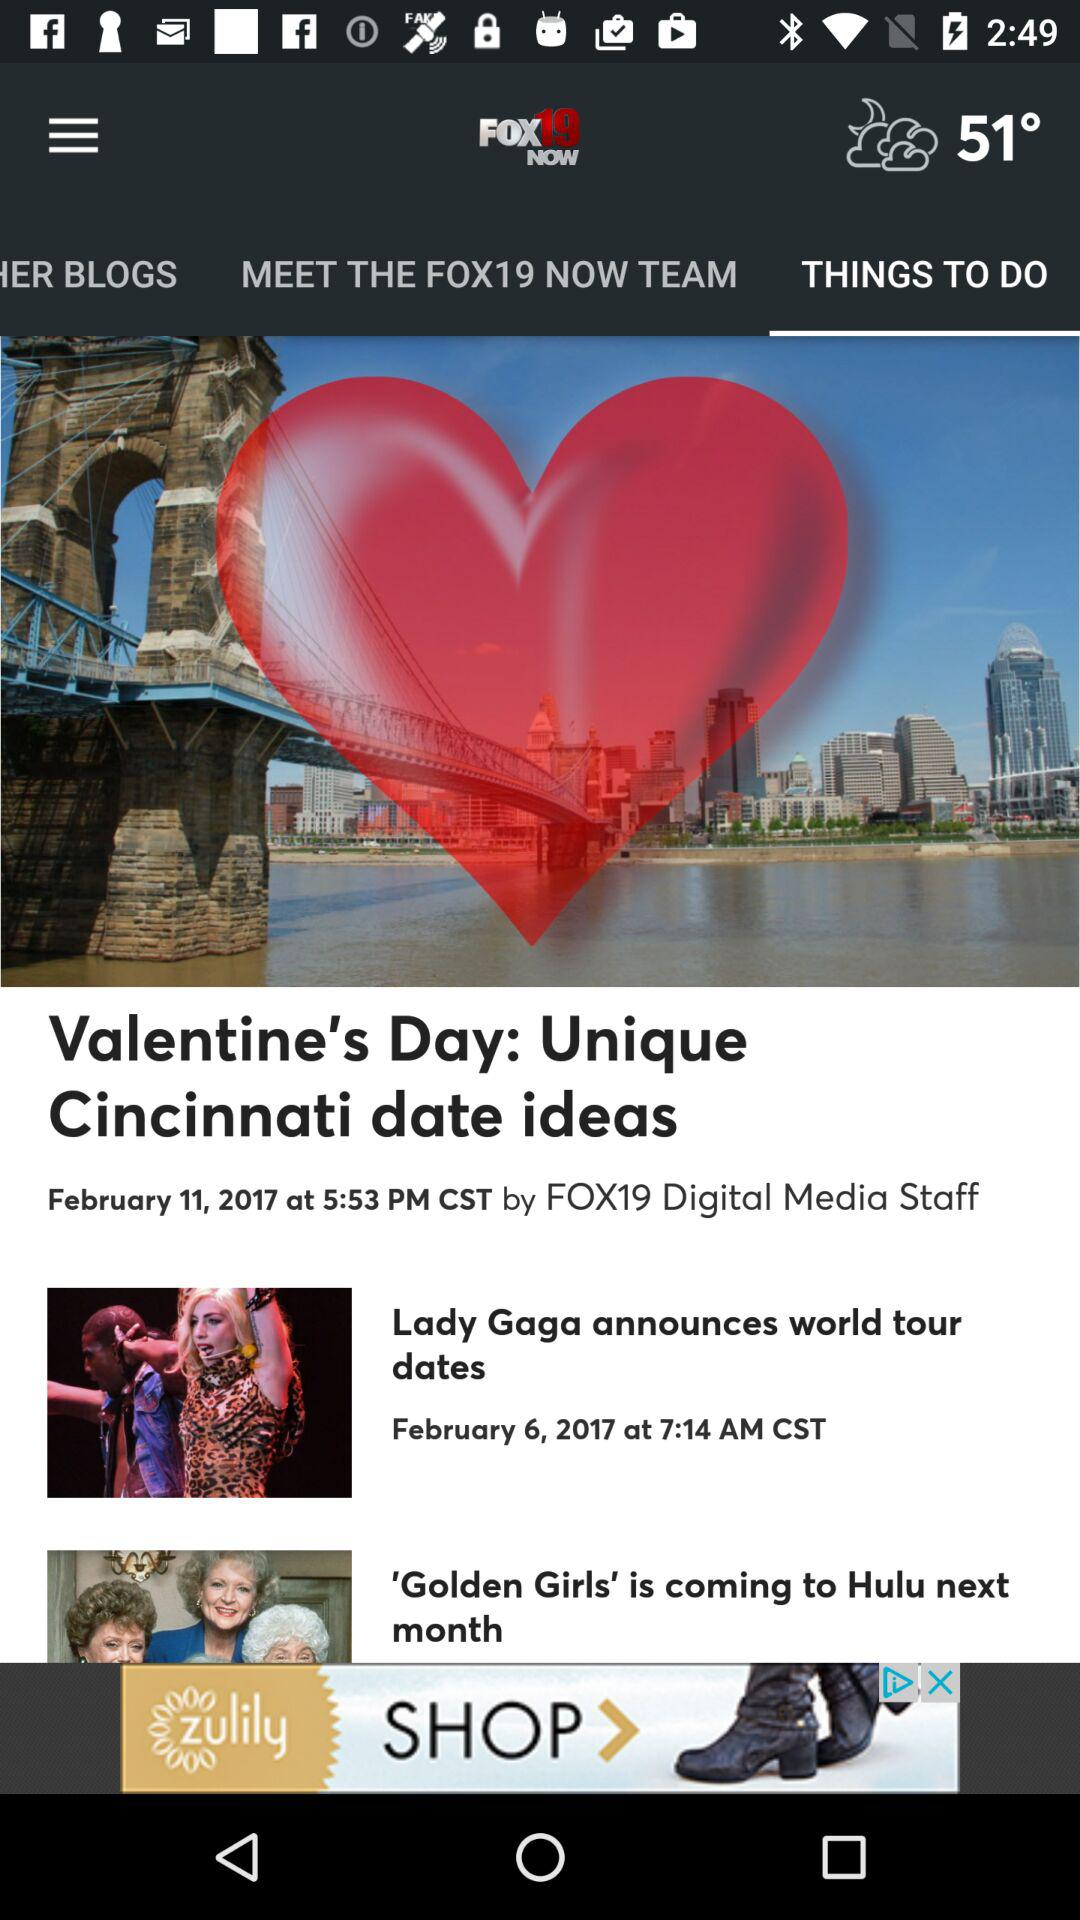What is the application name? The application name is "FOX19 NOW". 